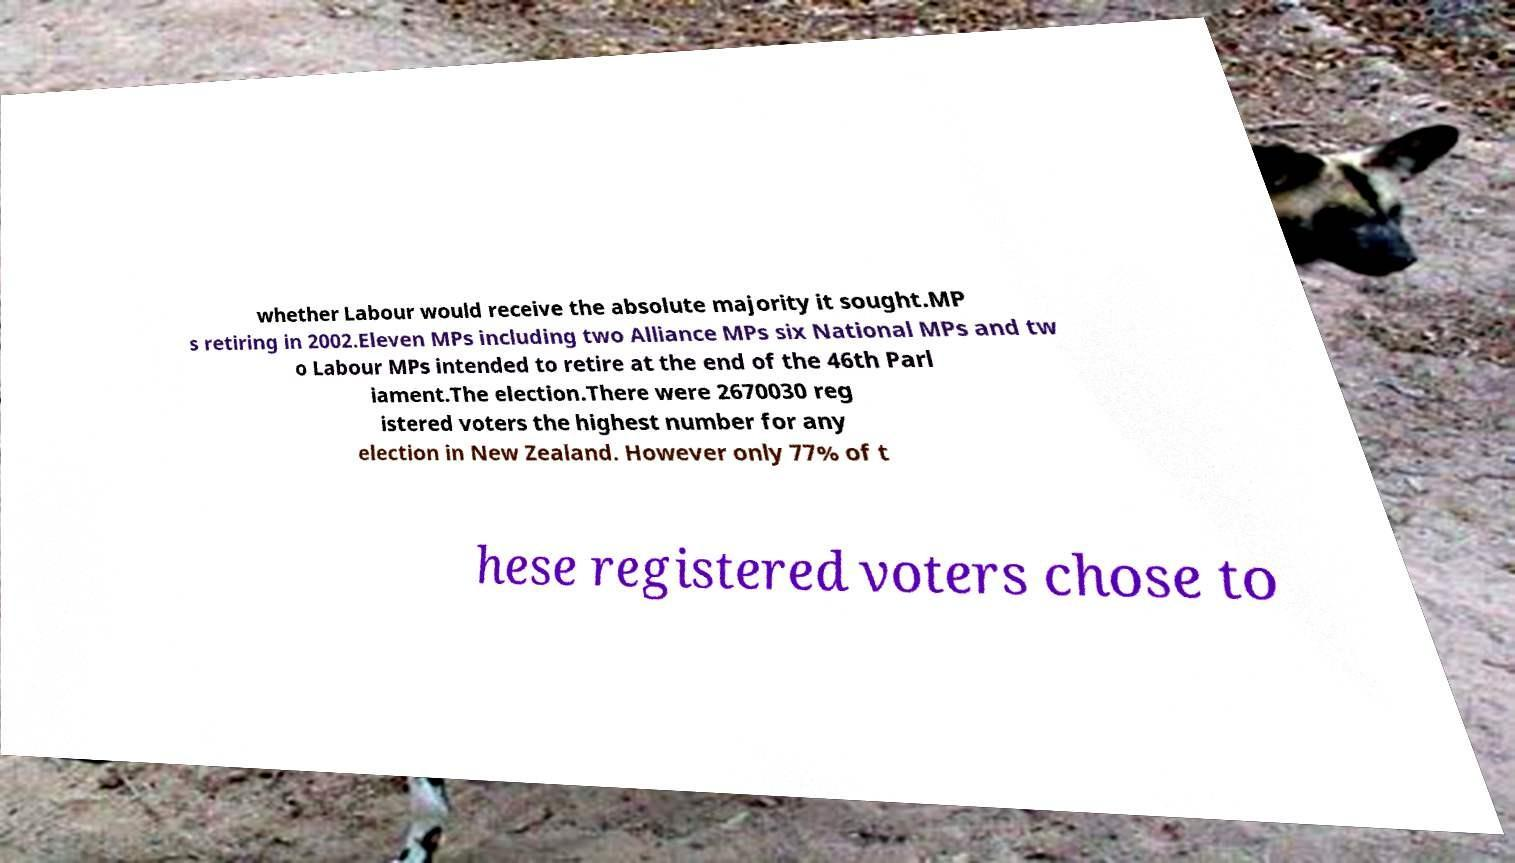Please read and relay the text visible in this image. What does it say? whether Labour would receive the absolute majority it sought.MP s retiring in 2002.Eleven MPs including two Alliance MPs six National MPs and tw o Labour MPs intended to retire at the end of the 46th Parl iament.The election.There were 2670030 reg istered voters the highest number for any election in New Zealand. However only 77% of t hese registered voters chose to 